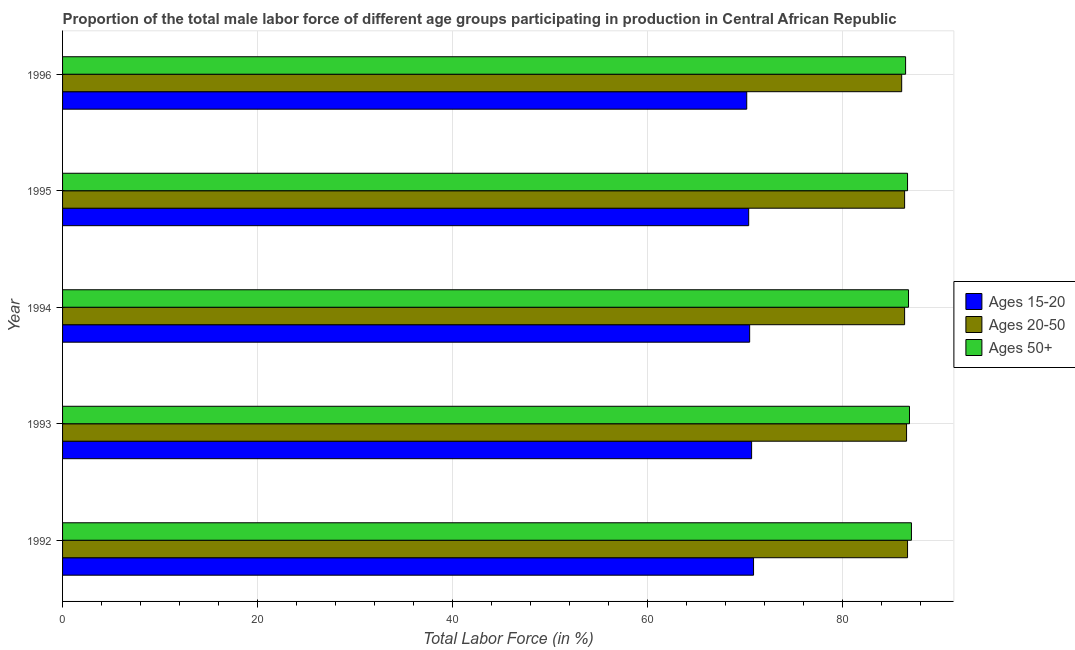How many different coloured bars are there?
Offer a terse response. 3. How many groups of bars are there?
Your answer should be very brief. 5. What is the label of the 2nd group of bars from the top?
Your answer should be very brief. 1995. What is the percentage of male labor force within the age group 15-20 in 1996?
Ensure brevity in your answer.  70.2. Across all years, what is the maximum percentage of male labor force above age 50?
Offer a very short reply. 87.1. Across all years, what is the minimum percentage of male labor force above age 50?
Your response must be concise. 86.5. In which year was the percentage of male labor force within the age group 15-20 maximum?
Provide a succinct answer. 1992. What is the total percentage of male labor force within the age group 15-20 in the graph?
Your response must be concise. 352.7. What is the difference between the percentage of male labor force within the age group 15-20 in 1993 and that in 1996?
Your response must be concise. 0.5. What is the difference between the percentage of male labor force within the age group 15-20 in 1994 and the percentage of male labor force within the age group 20-50 in 1992?
Keep it short and to the point. -16.2. What is the average percentage of male labor force within the age group 15-20 per year?
Keep it short and to the point. 70.54. In the year 1995, what is the difference between the percentage of male labor force within the age group 20-50 and percentage of male labor force within the age group 15-20?
Provide a short and direct response. 16. In how many years, is the percentage of male labor force within the age group 15-20 greater than 84 %?
Make the answer very short. 0. What is the ratio of the percentage of male labor force above age 50 in 1992 to that in 1994?
Your response must be concise. 1. What is the difference between the highest and the second highest percentage of male labor force within the age group 20-50?
Give a very brief answer. 0.1. Is the sum of the percentage of male labor force within the age group 15-20 in 1995 and 1996 greater than the maximum percentage of male labor force within the age group 20-50 across all years?
Provide a succinct answer. Yes. What does the 2nd bar from the top in 1994 represents?
Your answer should be compact. Ages 20-50. What does the 1st bar from the bottom in 1994 represents?
Provide a short and direct response. Ages 15-20. Is it the case that in every year, the sum of the percentage of male labor force within the age group 15-20 and percentage of male labor force within the age group 20-50 is greater than the percentage of male labor force above age 50?
Your answer should be compact. Yes. Are all the bars in the graph horizontal?
Provide a short and direct response. Yes. How many years are there in the graph?
Provide a short and direct response. 5. What is the difference between two consecutive major ticks on the X-axis?
Provide a short and direct response. 20. Does the graph contain any zero values?
Your answer should be very brief. No. Does the graph contain grids?
Give a very brief answer. Yes. How are the legend labels stacked?
Offer a very short reply. Vertical. What is the title of the graph?
Offer a terse response. Proportion of the total male labor force of different age groups participating in production in Central African Republic. Does "Private sector" appear as one of the legend labels in the graph?
Your response must be concise. No. What is the label or title of the Y-axis?
Your answer should be very brief. Year. What is the Total Labor Force (in %) in Ages 15-20 in 1992?
Your answer should be compact. 70.9. What is the Total Labor Force (in %) of Ages 20-50 in 1992?
Make the answer very short. 86.7. What is the Total Labor Force (in %) of Ages 50+ in 1992?
Your answer should be very brief. 87.1. What is the Total Labor Force (in %) in Ages 15-20 in 1993?
Provide a succinct answer. 70.7. What is the Total Labor Force (in %) of Ages 20-50 in 1993?
Ensure brevity in your answer.  86.6. What is the Total Labor Force (in %) in Ages 50+ in 1993?
Provide a short and direct response. 86.9. What is the Total Labor Force (in %) in Ages 15-20 in 1994?
Ensure brevity in your answer.  70.5. What is the Total Labor Force (in %) in Ages 20-50 in 1994?
Provide a succinct answer. 86.4. What is the Total Labor Force (in %) in Ages 50+ in 1994?
Your answer should be very brief. 86.8. What is the Total Labor Force (in %) of Ages 15-20 in 1995?
Keep it short and to the point. 70.4. What is the Total Labor Force (in %) in Ages 20-50 in 1995?
Keep it short and to the point. 86.4. What is the Total Labor Force (in %) in Ages 50+ in 1995?
Your answer should be compact. 86.7. What is the Total Labor Force (in %) of Ages 15-20 in 1996?
Provide a short and direct response. 70.2. What is the Total Labor Force (in %) of Ages 20-50 in 1996?
Your answer should be compact. 86.1. What is the Total Labor Force (in %) of Ages 50+ in 1996?
Your response must be concise. 86.5. Across all years, what is the maximum Total Labor Force (in %) of Ages 15-20?
Your answer should be compact. 70.9. Across all years, what is the maximum Total Labor Force (in %) of Ages 20-50?
Ensure brevity in your answer.  86.7. Across all years, what is the maximum Total Labor Force (in %) in Ages 50+?
Ensure brevity in your answer.  87.1. Across all years, what is the minimum Total Labor Force (in %) of Ages 15-20?
Keep it short and to the point. 70.2. Across all years, what is the minimum Total Labor Force (in %) in Ages 20-50?
Make the answer very short. 86.1. Across all years, what is the minimum Total Labor Force (in %) of Ages 50+?
Provide a short and direct response. 86.5. What is the total Total Labor Force (in %) in Ages 15-20 in the graph?
Provide a short and direct response. 352.7. What is the total Total Labor Force (in %) in Ages 20-50 in the graph?
Provide a succinct answer. 432.2. What is the total Total Labor Force (in %) in Ages 50+ in the graph?
Provide a short and direct response. 434. What is the difference between the Total Labor Force (in %) of Ages 20-50 in 1992 and that in 1993?
Keep it short and to the point. 0.1. What is the difference between the Total Labor Force (in %) of Ages 15-20 in 1992 and that in 1994?
Your response must be concise. 0.4. What is the difference between the Total Labor Force (in %) of Ages 20-50 in 1992 and that in 1994?
Provide a short and direct response. 0.3. What is the difference between the Total Labor Force (in %) of Ages 50+ in 1992 and that in 1994?
Your answer should be compact. 0.3. What is the difference between the Total Labor Force (in %) of Ages 15-20 in 1992 and that in 1995?
Keep it short and to the point. 0.5. What is the difference between the Total Labor Force (in %) in Ages 50+ in 1992 and that in 1995?
Provide a short and direct response. 0.4. What is the difference between the Total Labor Force (in %) in Ages 15-20 in 1992 and that in 1996?
Your answer should be compact. 0.7. What is the difference between the Total Labor Force (in %) in Ages 20-50 in 1992 and that in 1996?
Your response must be concise. 0.6. What is the difference between the Total Labor Force (in %) of Ages 20-50 in 1993 and that in 1994?
Your answer should be very brief. 0.2. What is the difference between the Total Labor Force (in %) of Ages 15-20 in 1993 and that in 1995?
Provide a succinct answer. 0.3. What is the difference between the Total Labor Force (in %) of Ages 20-50 in 1993 and that in 1995?
Keep it short and to the point. 0.2. What is the difference between the Total Labor Force (in %) in Ages 50+ in 1993 and that in 1995?
Ensure brevity in your answer.  0.2. What is the difference between the Total Labor Force (in %) of Ages 20-50 in 1993 and that in 1996?
Make the answer very short. 0.5. What is the difference between the Total Labor Force (in %) of Ages 15-20 in 1994 and that in 1995?
Ensure brevity in your answer.  0.1. What is the difference between the Total Labor Force (in %) in Ages 15-20 in 1994 and that in 1996?
Keep it short and to the point. 0.3. What is the difference between the Total Labor Force (in %) in Ages 50+ in 1994 and that in 1996?
Offer a terse response. 0.3. What is the difference between the Total Labor Force (in %) in Ages 15-20 in 1992 and the Total Labor Force (in %) in Ages 20-50 in 1993?
Ensure brevity in your answer.  -15.7. What is the difference between the Total Labor Force (in %) in Ages 15-20 in 1992 and the Total Labor Force (in %) in Ages 50+ in 1993?
Give a very brief answer. -16. What is the difference between the Total Labor Force (in %) of Ages 20-50 in 1992 and the Total Labor Force (in %) of Ages 50+ in 1993?
Provide a short and direct response. -0.2. What is the difference between the Total Labor Force (in %) of Ages 15-20 in 1992 and the Total Labor Force (in %) of Ages 20-50 in 1994?
Your response must be concise. -15.5. What is the difference between the Total Labor Force (in %) of Ages 15-20 in 1992 and the Total Labor Force (in %) of Ages 50+ in 1994?
Provide a short and direct response. -15.9. What is the difference between the Total Labor Force (in %) of Ages 20-50 in 1992 and the Total Labor Force (in %) of Ages 50+ in 1994?
Provide a succinct answer. -0.1. What is the difference between the Total Labor Force (in %) of Ages 15-20 in 1992 and the Total Labor Force (in %) of Ages 20-50 in 1995?
Ensure brevity in your answer.  -15.5. What is the difference between the Total Labor Force (in %) in Ages 15-20 in 1992 and the Total Labor Force (in %) in Ages 50+ in 1995?
Your answer should be compact. -15.8. What is the difference between the Total Labor Force (in %) of Ages 20-50 in 1992 and the Total Labor Force (in %) of Ages 50+ in 1995?
Provide a short and direct response. 0. What is the difference between the Total Labor Force (in %) in Ages 15-20 in 1992 and the Total Labor Force (in %) in Ages 20-50 in 1996?
Give a very brief answer. -15.2. What is the difference between the Total Labor Force (in %) in Ages 15-20 in 1992 and the Total Labor Force (in %) in Ages 50+ in 1996?
Your response must be concise. -15.6. What is the difference between the Total Labor Force (in %) of Ages 15-20 in 1993 and the Total Labor Force (in %) of Ages 20-50 in 1994?
Make the answer very short. -15.7. What is the difference between the Total Labor Force (in %) in Ages 15-20 in 1993 and the Total Labor Force (in %) in Ages 50+ in 1994?
Ensure brevity in your answer.  -16.1. What is the difference between the Total Labor Force (in %) in Ages 15-20 in 1993 and the Total Labor Force (in %) in Ages 20-50 in 1995?
Your answer should be compact. -15.7. What is the difference between the Total Labor Force (in %) in Ages 15-20 in 1993 and the Total Labor Force (in %) in Ages 50+ in 1995?
Give a very brief answer. -16. What is the difference between the Total Labor Force (in %) of Ages 15-20 in 1993 and the Total Labor Force (in %) of Ages 20-50 in 1996?
Your answer should be very brief. -15.4. What is the difference between the Total Labor Force (in %) of Ages 15-20 in 1993 and the Total Labor Force (in %) of Ages 50+ in 1996?
Offer a terse response. -15.8. What is the difference between the Total Labor Force (in %) of Ages 20-50 in 1993 and the Total Labor Force (in %) of Ages 50+ in 1996?
Offer a very short reply. 0.1. What is the difference between the Total Labor Force (in %) in Ages 15-20 in 1994 and the Total Labor Force (in %) in Ages 20-50 in 1995?
Your response must be concise. -15.9. What is the difference between the Total Labor Force (in %) of Ages 15-20 in 1994 and the Total Labor Force (in %) of Ages 50+ in 1995?
Make the answer very short. -16.2. What is the difference between the Total Labor Force (in %) in Ages 15-20 in 1994 and the Total Labor Force (in %) in Ages 20-50 in 1996?
Your response must be concise. -15.6. What is the difference between the Total Labor Force (in %) in Ages 15-20 in 1994 and the Total Labor Force (in %) in Ages 50+ in 1996?
Your answer should be very brief. -16. What is the difference between the Total Labor Force (in %) in Ages 15-20 in 1995 and the Total Labor Force (in %) in Ages 20-50 in 1996?
Offer a very short reply. -15.7. What is the difference between the Total Labor Force (in %) of Ages 15-20 in 1995 and the Total Labor Force (in %) of Ages 50+ in 1996?
Offer a very short reply. -16.1. What is the average Total Labor Force (in %) in Ages 15-20 per year?
Give a very brief answer. 70.54. What is the average Total Labor Force (in %) in Ages 20-50 per year?
Provide a short and direct response. 86.44. What is the average Total Labor Force (in %) of Ages 50+ per year?
Your answer should be very brief. 86.8. In the year 1992, what is the difference between the Total Labor Force (in %) in Ages 15-20 and Total Labor Force (in %) in Ages 20-50?
Make the answer very short. -15.8. In the year 1992, what is the difference between the Total Labor Force (in %) of Ages 15-20 and Total Labor Force (in %) of Ages 50+?
Provide a short and direct response. -16.2. In the year 1993, what is the difference between the Total Labor Force (in %) in Ages 15-20 and Total Labor Force (in %) in Ages 20-50?
Your response must be concise. -15.9. In the year 1993, what is the difference between the Total Labor Force (in %) of Ages 15-20 and Total Labor Force (in %) of Ages 50+?
Provide a short and direct response. -16.2. In the year 1994, what is the difference between the Total Labor Force (in %) of Ages 15-20 and Total Labor Force (in %) of Ages 20-50?
Provide a short and direct response. -15.9. In the year 1994, what is the difference between the Total Labor Force (in %) in Ages 15-20 and Total Labor Force (in %) in Ages 50+?
Offer a very short reply. -16.3. In the year 1995, what is the difference between the Total Labor Force (in %) of Ages 15-20 and Total Labor Force (in %) of Ages 50+?
Your answer should be compact. -16.3. In the year 1996, what is the difference between the Total Labor Force (in %) of Ages 15-20 and Total Labor Force (in %) of Ages 20-50?
Ensure brevity in your answer.  -15.9. In the year 1996, what is the difference between the Total Labor Force (in %) of Ages 15-20 and Total Labor Force (in %) of Ages 50+?
Your answer should be very brief. -16.3. What is the ratio of the Total Labor Force (in %) in Ages 15-20 in 1992 to that in 1993?
Provide a succinct answer. 1. What is the ratio of the Total Labor Force (in %) of Ages 20-50 in 1992 to that in 1993?
Provide a succinct answer. 1. What is the ratio of the Total Labor Force (in %) of Ages 15-20 in 1992 to that in 1994?
Ensure brevity in your answer.  1.01. What is the ratio of the Total Labor Force (in %) of Ages 20-50 in 1992 to that in 1994?
Offer a terse response. 1. What is the ratio of the Total Labor Force (in %) in Ages 50+ in 1992 to that in 1994?
Offer a very short reply. 1. What is the ratio of the Total Labor Force (in %) in Ages 15-20 in 1992 to that in 1995?
Your answer should be compact. 1.01. What is the ratio of the Total Labor Force (in %) of Ages 20-50 in 1992 to that in 1996?
Your answer should be compact. 1.01. What is the ratio of the Total Labor Force (in %) of Ages 15-20 in 1993 to that in 1994?
Your answer should be compact. 1. What is the ratio of the Total Labor Force (in %) in Ages 20-50 in 1993 to that in 1994?
Offer a very short reply. 1. What is the ratio of the Total Labor Force (in %) in Ages 15-20 in 1993 to that in 1995?
Your answer should be compact. 1. What is the ratio of the Total Labor Force (in %) of Ages 15-20 in 1993 to that in 1996?
Give a very brief answer. 1.01. What is the ratio of the Total Labor Force (in %) of Ages 20-50 in 1994 to that in 1995?
Offer a terse response. 1. What is the ratio of the Total Labor Force (in %) in Ages 50+ in 1994 to that in 1995?
Provide a short and direct response. 1. What is the ratio of the Total Labor Force (in %) in Ages 20-50 in 1994 to that in 1996?
Ensure brevity in your answer.  1. What is the ratio of the Total Labor Force (in %) of Ages 50+ in 1994 to that in 1996?
Your response must be concise. 1. What is the ratio of the Total Labor Force (in %) in Ages 15-20 in 1995 to that in 1996?
Offer a terse response. 1. What is the difference between the highest and the second highest Total Labor Force (in %) of Ages 15-20?
Provide a short and direct response. 0.2. What is the difference between the highest and the second highest Total Labor Force (in %) in Ages 20-50?
Provide a succinct answer. 0.1. What is the difference between the highest and the second highest Total Labor Force (in %) of Ages 50+?
Provide a succinct answer. 0.2. What is the difference between the highest and the lowest Total Labor Force (in %) in Ages 15-20?
Your answer should be compact. 0.7. What is the difference between the highest and the lowest Total Labor Force (in %) in Ages 50+?
Your answer should be compact. 0.6. 